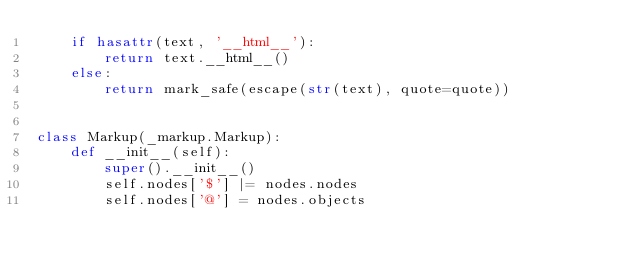Convert code to text. <code><loc_0><loc_0><loc_500><loc_500><_Python_>    if hasattr(text, '__html__'):
        return text.__html__()
    else:
        return mark_safe(escape(str(text), quote=quote))


class Markup(_markup.Markup):
    def __init__(self):
        super().__init__()
        self.nodes['$'] |= nodes.nodes
        self.nodes['@'] = nodes.objects
</code> 